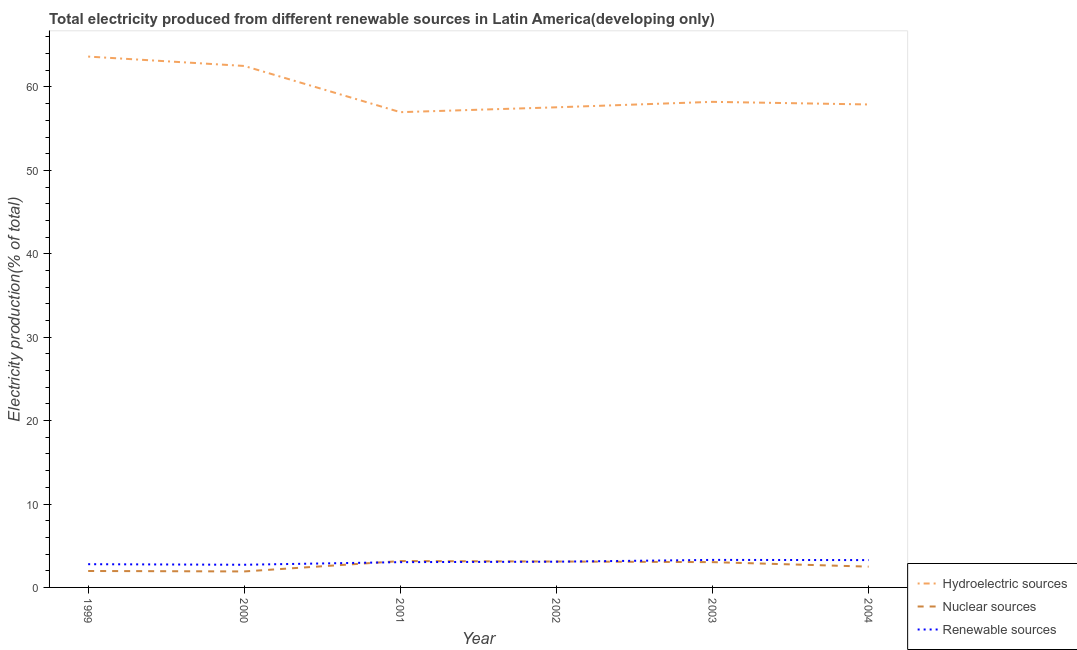How many different coloured lines are there?
Give a very brief answer. 3. Does the line corresponding to percentage of electricity produced by nuclear sources intersect with the line corresponding to percentage of electricity produced by hydroelectric sources?
Keep it short and to the point. No. Is the number of lines equal to the number of legend labels?
Provide a succinct answer. Yes. What is the percentage of electricity produced by hydroelectric sources in 2001?
Your response must be concise. 56.98. Across all years, what is the maximum percentage of electricity produced by nuclear sources?
Offer a very short reply. 3.16. Across all years, what is the minimum percentage of electricity produced by nuclear sources?
Give a very brief answer. 1.92. In which year was the percentage of electricity produced by renewable sources maximum?
Give a very brief answer. 2003. In which year was the percentage of electricity produced by hydroelectric sources minimum?
Give a very brief answer. 2001. What is the total percentage of electricity produced by hydroelectric sources in the graph?
Give a very brief answer. 356.83. What is the difference between the percentage of electricity produced by nuclear sources in 1999 and that in 2001?
Your response must be concise. -1.19. What is the difference between the percentage of electricity produced by nuclear sources in 1999 and the percentage of electricity produced by hydroelectric sources in 2002?
Keep it short and to the point. -55.59. What is the average percentage of electricity produced by renewable sources per year?
Ensure brevity in your answer.  3.03. In the year 2000, what is the difference between the percentage of electricity produced by renewable sources and percentage of electricity produced by nuclear sources?
Make the answer very short. 0.8. What is the ratio of the percentage of electricity produced by renewable sources in 1999 to that in 2000?
Your answer should be very brief. 1.02. Is the difference between the percentage of electricity produced by hydroelectric sources in 1999 and 2002 greater than the difference between the percentage of electricity produced by nuclear sources in 1999 and 2002?
Offer a very short reply. Yes. What is the difference between the highest and the second highest percentage of electricity produced by nuclear sources?
Your response must be concise. 0.05. What is the difference between the highest and the lowest percentage of electricity produced by nuclear sources?
Provide a succinct answer. 1.24. Is it the case that in every year, the sum of the percentage of electricity produced by hydroelectric sources and percentage of electricity produced by nuclear sources is greater than the percentage of electricity produced by renewable sources?
Your answer should be compact. Yes. Is the percentage of electricity produced by nuclear sources strictly less than the percentage of electricity produced by hydroelectric sources over the years?
Offer a very short reply. Yes. Does the graph contain grids?
Provide a succinct answer. No. What is the title of the graph?
Your answer should be compact. Total electricity produced from different renewable sources in Latin America(developing only). What is the label or title of the X-axis?
Offer a terse response. Year. What is the Electricity production(% of total) of Hydroelectric sources in 1999?
Your answer should be very brief. 63.65. What is the Electricity production(% of total) of Nuclear sources in 1999?
Provide a short and direct response. 1.97. What is the Electricity production(% of total) of Renewable sources in 1999?
Your answer should be very brief. 2.79. What is the Electricity production(% of total) of Hydroelectric sources in 2000?
Offer a very short reply. 62.52. What is the Electricity production(% of total) in Nuclear sources in 2000?
Your answer should be very brief. 1.92. What is the Electricity production(% of total) of Renewable sources in 2000?
Your answer should be very brief. 2.72. What is the Electricity production(% of total) of Hydroelectric sources in 2001?
Your answer should be compact. 56.98. What is the Electricity production(% of total) in Nuclear sources in 2001?
Offer a terse response. 3.16. What is the Electricity production(% of total) of Renewable sources in 2001?
Ensure brevity in your answer.  3.03. What is the Electricity production(% of total) in Hydroelectric sources in 2002?
Offer a terse response. 57.56. What is the Electricity production(% of total) in Nuclear sources in 2002?
Offer a terse response. 3.11. What is the Electricity production(% of total) in Renewable sources in 2002?
Provide a succinct answer. 3.09. What is the Electricity production(% of total) in Hydroelectric sources in 2003?
Provide a succinct answer. 58.22. What is the Electricity production(% of total) in Nuclear sources in 2003?
Your answer should be compact. 3.03. What is the Electricity production(% of total) in Renewable sources in 2003?
Your response must be concise. 3.3. What is the Electricity production(% of total) of Hydroelectric sources in 2004?
Your answer should be very brief. 57.9. What is the Electricity production(% of total) of Nuclear sources in 2004?
Provide a succinct answer. 2.49. What is the Electricity production(% of total) of Renewable sources in 2004?
Your answer should be very brief. 3.28. Across all years, what is the maximum Electricity production(% of total) in Hydroelectric sources?
Your response must be concise. 63.65. Across all years, what is the maximum Electricity production(% of total) of Nuclear sources?
Provide a short and direct response. 3.16. Across all years, what is the maximum Electricity production(% of total) of Renewable sources?
Your answer should be very brief. 3.3. Across all years, what is the minimum Electricity production(% of total) in Hydroelectric sources?
Make the answer very short. 56.98. Across all years, what is the minimum Electricity production(% of total) of Nuclear sources?
Ensure brevity in your answer.  1.92. Across all years, what is the minimum Electricity production(% of total) in Renewable sources?
Your answer should be compact. 2.72. What is the total Electricity production(% of total) of Hydroelectric sources in the graph?
Offer a terse response. 356.83. What is the total Electricity production(% of total) of Nuclear sources in the graph?
Provide a short and direct response. 15.68. What is the total Electricity production(% of total) of Renewable sources in the graph?
Keep it short and to the point. 18.2. What is the difference between the Electricity production(% of total) in Hydroelectric sources in 1999 and that in 2000?
Keep it short and to the point. 1.13. What is the difference between the Electricity production(% of total) of Nuclear sources in 1999 and that in 2000?
Provide a succinct answer. 0.05. What is the difference between the Electricity production(% of total) of Renewable sources in 1999 and that in 2000?
Keep it short and to the point. 0.07. What is the difference between the Electricity production(% of total) of Hydroelectric sources in 1999 and that in 2001?
Offer a terse response. 6.67. What is the difference between the Electricity production(% of total) of Nuclear sources in 1999 and that in 2001?
Provide a succinct answer. -1.19. What is the difference between the Electricity production(% of total) of Renewable sources in 1999 and that in 2001?
Ensure brevity in your answer.  -0.25. What is the difference between the Electricity production(% of total) of Hydroelectric sources in 1999 and that in 2002?
Your answer should be compact. 6.08. What is the difference between the Electricity production(% of total) in Nuclear sources in 1999 and that in 2002?
Your answer should be very brief. -1.14. What is the difference between the Electricity production(% of total) in Renewable sources in 1999 and that in 2002?
Your answer should be compact. -0.3. What is the difference between the Electricity production(% of total) in Hydroelectric sources in 1999 and that in 2003?
Your answer should be very brief. 5.43. What is the difference between the Electricity production(% of total) in Nuclear sources in 1999 and that in 2003?
Make the answer very short. -1.06. What is the difference between the Electricity production(% of total) in Renewable sources in 1999 and that in 2003?
Give a very brief answer. -0.51. What is the difference between the Electricity production(% of total) of Hydroelectric sources in 1999 and that in 2004?
Offer a very short reply. 5.74. What is the difference between the Electricity production(% of total) in Nuclear sources in 1999 and that in 2004?
Ensure brevity in your answer.  -0.52. What is the difference between the Electricity production(% of total) of Renewable sources in 1999 and that in 2004?
Offer a very short reply. -0.49. What is the difference between the Electricity production(% of total) in Hydroelectric sources in 2000 and that in 2001?
Your response must be concise. 5.54. What is the difference between the Electricity production(% of total) of Nuclear sources in 2000 and that in 2001?
Your response must be concise. -1.24. What is the difference between the Electricity production(% of total) of Renewable sources in 2000 and that in 2001?
Make the answer very short. -0.31. What is the difference between the Electricity production(% of total) of Hydroelectric sources in 2000 and that in 2002?
Your answer should be compact. 4.96. What is the difference between the Electricity production(% of total) in Nuclear sources in 2000 and that in 2002?
Your response must be concise. -1.19. What is the difference between the Electricity production(% of total) in Renewable sources in 2000 and that in 2002?
Ensure brevity in your answer.  -0.37. What is the difference between the Electricity production(% of total) of Hydroelectric sources in 2000 and that in 2003?
Give a very brief answer. 4.3. What is the difference between the Electricity production(% of total) of Nuclear sources in 2000 and that in 2003?
Offer a terse response. -1.12. What is the difference between the Electricity production(% of total) of Renewable sources in 2000 and that in 2003?
Keep it short and to the point. -0.58. What is the difference between the Electricity production(% of total) of Hydroelectric sources in 2000 and that in 2004?
Your response must be concise. 4.62. What is the difference between the Electricity production(% of total) in Nuclear sources in 2000 and that in 2004?
Offer a very short reply. -0.58. What is the difference between the Electricity production(% of total) of Renewable sources in 2000 and that in 2004?
Make the answer very short. -0.56. What is the difference between the Electricity production(% of total) of Hydroelectric sources in 2001 and that in 2002?
Provide a short and direct response. -0.58. What is the difference between the Electricity production(% of total) in Nuclear sources in 2001 and that in 2002?
Your answer should be compact. 0.05. What is the difference between the Electricity production(% of total) in Renewable sources in 2001 and that in 2002?
Provide a succinct answer. -0.05. What is the difference between the Electricity production(% of total) of Hydroelectric sources in 2001 and that in 2003?
Provide a succinct answer. -1.24. What is the difference between the Electricity production(% of total) of Nuclear sources in 2001 and that in 2003?
Keep it short and to the point. 0.13. What is the difference between the Electricity production(% of total) in Renewable sources in 2001 and that in 2003?
Provide a short and direct response. -0.27. What is the difference between the Electricity production(% of total) in Hydroelectric sources in 2001 and that in 2004?
Offer a terse response. -0.92. What is the difference between the Electricity production(% of total) in Nuclear sources in 2001 and that in 2004?
Give a very brief answer. 0.67. What is the difference between the Electricity production(% of total) of Renewable sources in 2001 and that in 2004?
Your response must be concise. -0.25. What is the difference between the Electricity production(% of total) in Hydroelectric sources in 2002 and that in 2003?
Provide a short and direct response. -0.65. What is the difference between the Electricity production(% of total) of Nuclear sources in 2002 and that in 2003?
Give a very brief answer. 0.07. What is the difference between the Electricity production(% of total) of Renewable sources in 2002 and that in 2003?
Provide a succinct answer. -0.21. What is the difference between the Electricity production(% of total) of Hydroelectric sources in 2002 and that in 2004?
Your response must be concise. -0.34. What is the difference between the Electricity production(% of total) in Nuclear sources in 2002 and that in 2004?
Keep it short and to the point. 0.62. What is the difference between the Electricity production(% of total) in Renewable sources in 2002 and that in 2004?
Provide a short and direct response. -0.19. What is the difference between the Electricity production(% of total) of Hydroelectric sources in 2003 and that in 2004?
Provide a succinct answer. 0.31. What is the difference between the Electricity production(% of total) in Nuclear sources in 2003 and that in 2004?
Keep it short and to the point. 0.54. What is the difference between the Electricity production(% of total) of Renewable sources in 2003 and that in 2004?
Your answer should be very brief. 0.02. What is the difference between the Electricity production(% of total) in Hydroelectric sources in 1999 and the Electricity production(% of total) in Nuclear sources in 2000?
Make the answer very short. 61.73. What is the difference between the Electricity production(% of total) of Hydroelectric sources in 1999 and the Electricity production(% of total) of Renewable sources in 2000?
Your response must be concise. 60.93. What is the difference between the Electricity production(% of total) in Nuclear sources in 1999 and the Electricity production(% of total) in Renewable sources in 2000?
Provide a short and direct response. -0.75. What is the difference between the Electricity production(% of total) of Hydroelectric sources in 1999 and the Electricity production(% of total) of Nuclear sources in 2001?
Your response must be concise. 60.49. What is the difference between the Electricity production(% of total) of Hydroelectric sources in 1999 and the Electricity production(% of total) of Renewable sources in 2001?
Give a very brief answer. 60.61. What is the difference between the Electricity production(% of total) of Nuclear sources in 1999 and the Electricity production(% of total) of Renewable sources in 2001?
Offer a terse response. -1.06. What is the difference between the Electricity production(% of total) of Hydroelectric sources in 1999 and the Electricity production(% of total) of Nuclear sources in 2002?
Provide a succinct answer. 60.54. What is the difference between the Electricity production(% of total) of Hydroelectric sources in 1999 and the Electricity production(% of total) of Renewable sources in 2002?
Your answer should be compact. 60.56. What is the difference between the Electricity production(% of total) of Nuclear sources in 1999 and the Electricity production(% of total) of Renewable sources in 2002?
Your response must be concise. -1.12. What is the difference between the Electricity production(% of total) of Hydroelectric sources in 1999 and the Electricity production(% of total) of Nuclear sources in 2003?
Give a very brief answer. 60.61. What is the difference between the Electricity production(% of total) in Hydroelectric sources in 1999 and the Electricity production(% of total) in Renewable sources in 2003?
Provide a succinct answer. 60.35. What is the difference between the Electricity production(% of total) of Nuclear sources in 1999 and the Electricity production(% of total) of Renewable sources in 2003?
Offer a very short reply. -1.33. What is the difference between the Electricity production(% of total) of Hydroelectric sources in 1999 and the Electricity production(% of total) of Nuclear sources in 2004?
Make the answer very short. 61.15. What is the difference between the Electricity production(% of total) of Hydroelectric sources in 1999 and the Electricity production(% of total) of Renewable sources in 2004?
Ensure brevity in your answer.  60.37. What is the difference between the Electricity production(% of total) in Nuclear sources in 1999 and the Electricity production(% of total) in Renewable sources in 2004?
Ensure brevity in your answer.  -1.31. What is the difference between the Electricity production(% of total) in Hydroelectric sources in 2000 and the Electricity production(% of total) in Nuclear sources in 2001?
Your response must be concise. 59.36. What is the difference between the Electricity production(% of total) in Hydroelectric sources in 2000 and the Electricity production(% of total) in Renewable sources in 2001?
Your response must be concise. 59.49. What is the difference between the Electricity production(% of total) in Nuclear sources in 2000 and the Electricity production(% of total) in Renewable sources in 2001?
Make the answer very short. -1.11. What is the difference between the Electricity production(% of total) of Hydroelectric sources in 2000 and the Electricity production(% of total) of Nuclear sources in 2002?
Ensure brevity in your answer.  59.41. What is the difference between the Electricity production(% of total) in Hydroelectric sources in 2000 and the Electricity production(% of total) in Renewable sources in 2002?
Your answer should be very brief. 59.43. What is the difference between the Electricity production(% of total) of Nuclear sources in 2000 and the Electricity production(% of total) of Renewable sources in 2002?
Make the answer very short. -1.17. What is the difference between the Electricity production(% of total) of Hydroelectric sources in 2000 and the Electricity production(% of total) of Nuclear sources in 2003?
Give a very brief answer. 59.49. What is the difference between the Electricity production(% of total) in Hydroelectric sources in 2000 and the Electricity production(% of total) in Renewable sources in 2003?
Your answer should be compact. 59.22. What is the difference between the Electricity production(% of total) in Nuclear sources in 2000 and the Electricity production(% of total) in Renewable sources in 2003?
Keep it short and to the point. -1.38. What is the difference between the Electricity production(% of total) in Hydroelectric sources in 2000 and the Electricity production(% of total) in Nuclear sources in 2004?
Provide a succinct answer. 60.03. What is the difference between the Electricity production(% of total) in Hydroelectric sources in 2000 and the Electricity production(% of total) in Renewable sources in 2004?
Your answer should be very brief. 59.24. What is the difference between the Electricity production(% of total) of Nuclear sources in 2000 and the Electricity production(% of total) of Renewable sources in 2004?
Give a very brief answer. -1.36. What is the difference between the Electricity production(% of total) of Hydroelectric sources in 2001 and the Electricity production(% of total) of Nuclear sources in 2002?
Give a very brief answer. 53.87. What is the difference between the Electricity production(% of total) of Hydroelectric sources in 2001 and the Electricity production(% of total) of Renewable sources in 2002?
Your answer should be compact. 53.89. What is the difference between the Electricity production(% of total) of Nuclear sources in 2001 and the Electricity production(% of total) of Renewable sources in 2002?
Provide a succinct answer. 0.07. What is the difference between the Electricity production(% of total) in Hydroelectric sources in 2001 and the Electricity production(% of total) in Nuclear sources in 2003?
Give a very brief answer. 53.95. What is the difference between the Electricity production(% of total) of Hydroelectric sources in 2001 and the Electricity production(% of total) of Renewable sources in 2003?
Provide a succinct answer. 53.68. What is the difference between the Electricity production(% of total) of Nuclear sources in 2001 and the Electricity production(% of total) of Renewable sources in 2003?
Your answer should be very brief. -0.14. What is the difference between the Electricity production(% of total) of Hydroelectric sources in 2001 and the Electricity production(% of total) of Nuclear sources in 2004?
Your response must be concise. 54.49. What is the difference between the Electricity production(% of total) in Hydroelectric sources in 2001 and the Electricity production(% of total) in Renewable sources in 2004?
Provide a succinct answer. 53.7. What is the difference between the Electricity production(% of total) in Nuclear sources in 2001 and the Electricity production(% of total) in Renewable sources in 2004?
Ensure brevity in your answer.  -0.12. What is the difference between the Electricity production(% of total) in Hydroelectric sources in 2002 and the Electricity production(% of total) in Nuclear sources in 2003?
Provide a short and direct response. 54.53. What is the difference between the Electricity production(% of total) in Hydroelectric sources in 2002 and the Electricity production(% of total) in Renewable sources in 2003?
Provide a succinct answer. 54.26. What is the difference between the Electricity production(% of total) of Nuclear sources in 2002 and the Electricity production(% of total) of Renewable sources in 2003?
Make the answer very short. -0.19. What is the difference between the Electricity production(% of total) of Hydroelectric sources in 2002 and the Electricity production(% of total) of Nuclear sources in 2004?
Keep it short and to the point. 55.07. What is the difference between the Electricity production(% of total) in Hydroelectric sources in 2002 and the Electricity production(% of total) in Renewable sources in 2004?
Give a very brief answer. 54.29. What is the difference between the Electricity production(% of total) in Nuclear sources in 2002 and the Electricity production(% of total) in Renewable sources in 2004?
Make the answer very short. -0.17. What is the difference between the Electricity production(% of total) in Hydroelectric sources in 2003 and the Electricity production(% of total) in Nuclear sources in 2004?
Give a very brief answer. 55.72. What is the difference between the Electricity production(% of total) in Hydroelectric sources in 2003 and the Electricity production(% of total) in Renewable sources in 2004?
Offer a very short reply. 54.94. What is the difference between the Electricity production(% of total) of Nuclear sources in 2003 and the Electricity production(% of total) of Renewable sources in 2004?
Offer a very short reply. -0.24. What is the average Electricity production(% of total) in Hydroelectric sources per year?
Offer a terse response. 59.47. What is the average Electricity production(% of total) of Nuclear sources per year?
Provide a succinct answer. 2.61. What is the average Electricity production(% of total) in Renewable sources per year?
Offer a terse response. 3.03. In the year 1999, what is the difference between the Electricity production(% of total) of Hydroelectric sources and Electricity production(% of total) of Nuclear sources?
Provide a succinct answer. 61.68. In the year 1999, what is the difference between the Electricity production(% of total) in Hydroelectric sources and Electricity production(% of total) in Renewable sources?
Your response must be concise. 60.86. In the year 1999, what is the difference between the Electricity production(% of total) of Nuclear sources and Electricity production(% of total) of Renewable sources?
Ensure brevity in your answer.  -0.82. In the year 2000, what is the difference between the Electricity production(% of total) in Hydroelectric sources and Electricity production(% of total) in Nuclear sources?
Give a very brief answer. 60.6. In the year 2000, what is the difference between the Electricity production(% of total) of Hydroelectric sources and Electricity production(% of total) of Renewable sources?
Your response must be concise. 59.8. In the year 2000, what is the difference between the Electricity production(% of total) in Nuclear sources and Electricity production(% of total) in Renewable sources?
Your response must be concise. -0.8. In the year 2001, what is the difference between the Electricity production(% of total) of Hydroelectric sources and Electricity production(% of total) of Nuclear sources?
Your answer should be compact. 53.82. In the year 2001, what is the difference between the Electricity production(% of total) of Hydroelectric sources and Electricity production(% of total) of Renewable sources?
Your response must be concise. 53.95. In the year 2001, what is the difference between the Electricity production(% of total) of Nuclear sources and Electricity production(% of total) of Renewable sources?
Provide a succinct answer. 0.13. In the year 2002, what is the difference between the Electricity production(% of total) in Hydroelectric sources and Electricity production(% of total) in Nuclear sources?
Provide a succinct answer. 54.46. In the year 2002, what is the difference between the Electricity production(% of total) in Hydroelectric sources and Electricity production(% of total) in Renewable sources?
Your answer should be compact. 54.48. In the year 2002, what is the difference between the Electricity production(% of total) of Nuclear sources and Electricity production(% of total) of Renewable sources?
Provide a short and direct response. 0.02. In the year 2003, what is the difference between the Electricity production(% of total) of Hydroelectric sources and Electricity production(% of total) of Nuclear sources?
Give a very brief answer. 55.18. In the year 2003, what is the difference between the Electricity production(% of total) of Hydroelectric sources and Electricity production(% of total) of Renewable sources?
Ensure brevity in your answer.  54.92. In the year 2003, what is the difference between the Electricity production(% of total) in Nuclear sources and Electricity production(% of total) in Renewable sources?
Offer a terse response. -0.27. In the year 2004, what is the difference between the Electricity production(% of total) in Hydroelectric sources and Electricity production(% of total) in Nuclear sources?
Give a very brief answer. 55.41. In the year 2004, what is the difference between the Electricity production(% of total) in Hydroelectric sources and Electricity production(% of total) in Renewable sources?
Your answer should be compact. 54.63. In the year 2004, what is the difference between the Electricity production(% of total) of Nuclear sources and Electricity production(% of total) of Renewable sources?
Your answer should be compact. -0.79. What is the ratio of the Electricity production(% of total) of Nuclear sources in 1999 to that in 2000?
Provide a succinct answer. 1.03. What is the ratio of the Electricity production(% of total) of Renewable sources in 1999 to that in 2000?
Keep it short and to the point. 1.02. What is the ratio of the Electricity production(% of total) in Hydroelectric sources in 1999 to that in 2001?
Ensure brevity in your answer.  1.12. What is the ratio of the Electricity production(% of total) in Nuclear sources in 1999 to that in 2001?
Provide a succinct answer. 0.62. What is the ratio of the Electricity production(% of total) of Renewable sources in 1999 to that in 2001?
Your answer should be very brief. 0.92. What is the ratio of the Electricity production(% of total) in Hydroelectric sources in 1999 to that in 2002?
Offer a terse response. 1.11. What is the ratio of the Electricity production(% of total) of Nuclear sources in 1999 to that in 2002?
Offer a terse response. 0.63. What is the ratio of the Electricity production(% of total) in Renewable sources in 1999 to that in 2002?
Make the answer very short. 0.9. What is the ratio of the Electricity production(% of total) in Hydroelectric sources in 1999 to that in 2003?
Your response must be concise. 1.09. What is the ratio of the Electricity production(% of total) of Nuclear sources in 1999 to that in 2003?
Ensure brevity in your answer.  0.65. What is the ratio of the Electricity production(% of total) of Renewable sources in 1999 to that in 2003?
Provide a succinct answer. 0.84. What is the ratio of the Electricity production(% of total) in Hydroelectric sources in 1999 to that in 2004?
Give a very brief answer. 1.1. What is the ratio of the Electricity production(% of total) in Nuclear sources in 1999 to that in 2004?
Your response must be concise. 0.79. What is the ratio of the Electricity production(% of total) in Renewable sources in 1999 to that in 2004?
Provide a short and direct response. 0.85. What is the ratio of the Electricity production(% of total) of Hydroelectric sources in 2000 to that in 2001?
Provide a short and direct response. 1.1. What is the ratio of the Electricity production(% of total) of Nuclear sources in 2000 to that in 2001?
Offer a very short reply. 0.61. What is the ratio of the Electricity production(% of total) in Renewable sources in 2000 to that in 2001?
Ensure brevity in your answer.  0.9. What is the ratio of the Electricity production(% of total) in Hydroelectric sources in 2000 to that in 2002?
Ensure brevity in your answer.  1.09. What is the ratio of the Electricity production(% of total) in Nuclear sources in 2000 to that in 2002?
Ensure brevity in your answer.  0.62. What is the ratio of the Electricity production(% of total) of Renewable sources in 2000 to that in 2002?
Your answer should be very brief. 0.88. What is the ratio of the Electricity production(% of total) in Hydroelectric sources in 2000 to that in 2003?
Offer a very short reply. 1.07. What is the ratio of the Electricity production(% of total) of Nuclear sources in 2000 to that in 2003?
Provide a succinct answer. 0.63. What is the ratio of the Electricity production(% of total) of Renewable sources in 2000 to that in 2003?
Offer a terse response. 0.82. What is the ratio of the Electricity production(% of total) in Hydroelectric sources in 2000 to that in 2004?
Your response must be concise. 1.08. What is the ratio of the Electricity production(% of total) of Nuclear sources in 2000 to that in 2004?
Keep it short and to the point. 0.77. What is the ratio of the Electricity production(% of total) of Renewable sources in 2000 to that in 2004?
Give a very brief answer. 0.83. What is the ratio of the Electricity production(% of total) in Hydroelectric sources in 2001 to that in 2002?
Your answer should be compact. 0.99. What is the ratio of the Electricity production(% of total) in Nuclear sources in 2001 to that in 2002?
Your answer should be compact. 1.02. What is the ratio of the Electricity production(% of total) of Renewable sources in 2001 to that in 2002?
Offer a very short reply. 0.98. What is the ratio of the Electricity production(% of total) in Hydroelectric sources in 2001 to that in 2003?
Your response must be concise. 0.98. What is the ratio of the Electricity production(% of total) in Nuclear sources in 2001 to that in 2003?
Provide a succinct answer. 1.04. What is the ratio of the Electricity production(% of total) of Renewable sources in 2001 to that in 2003?
Provide a succinct answer. 0.92. What is the ratio of the Electricity production(% of total) in Hydroelectric sources in 2001 to that in 2004?
Provide a short and direct response. 0.98. What is the ratio of the Electricity production(% of total) in Nuclear sources in 2001 to that in 2004?
Offer a terse response. 1.27. What is the ratio of the Electricity production(% of total) of Renewable sources in 2001 to that in 2004?
Keep it short and to the point. 0.92. What is the ratio of the Electricity production(% of total) in Nuclear sources in 2002 to that in 2003?
Keep it short and to the point. 1.02. What is the ratio of the Electricity production(% of total) of Renewable sources in 2002 to that in 2003?
Offer a very short reply. 0.94. What is the ratio of the Electricity production(% of total) of Hydroelectric sources in 2002 to that in 2004?
Your answer should be very brief. 0.99. What is the ratio of the Electricity production(% of total) of Nuclear sources in 2002 to that in 2004?
Your response must be concise. 1.25. What is the ratio of the Electricity production(% of total) of Renewable sources in 2002 to that in 2004?
Ensure brevity in your answer.  0.94. What is the ratio of the Electricity production(% of total) in Hydroelectric sources in 2003 to that in 2004?
Your response must be concise. 1.01. What is the ratio of the Electricity production(% of total) in Nuclear sources in 2003 to that in 2004?
Your response must be concise. 1.22. What is the ratio of the Electricity production(% of total) of Renewable sources in 2003 to that in 2004?
Give a very brief answer. 1.01. What is the difference between the highest and the second highest Electricity production(% of total) of Hydroelectric sources?
Give a very brief answer. 1.13. What is the difference between the highest and the second highest Electricity production(% of total) in Nuclear sources?
Your response must be concise. 0.05. What is the difference between the highest and the second highest Electricity production(% of total) in Renewable sources?
Ensure brevity in your answer.  0.02. What is the difference between the highest and the lowest Electricity production(% of total) of Hydroelectric sources?
Provide a short and direct response. 6.67. What is the difference between the highest and the lowest Electricity production(% of total) of Nuclear sources?
Make the answer very short. 1.24. What is the difference between the highest and the lowest Electricity production(% of total) of Renewable sources?
Offer a terse response. 0.58. 